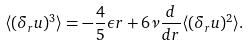<formula> <loc_0><loc_0><loc_500><loc_500>\langle ( \delta _ { r } u ) ^ { 3 } \rangle = - \frac { 4 } { 5 } \epsilon r + 6 \nu \frac { d } { d r } \langle ( \delta _ { r } u ) ^ { 2 } \rangle .</formula> 